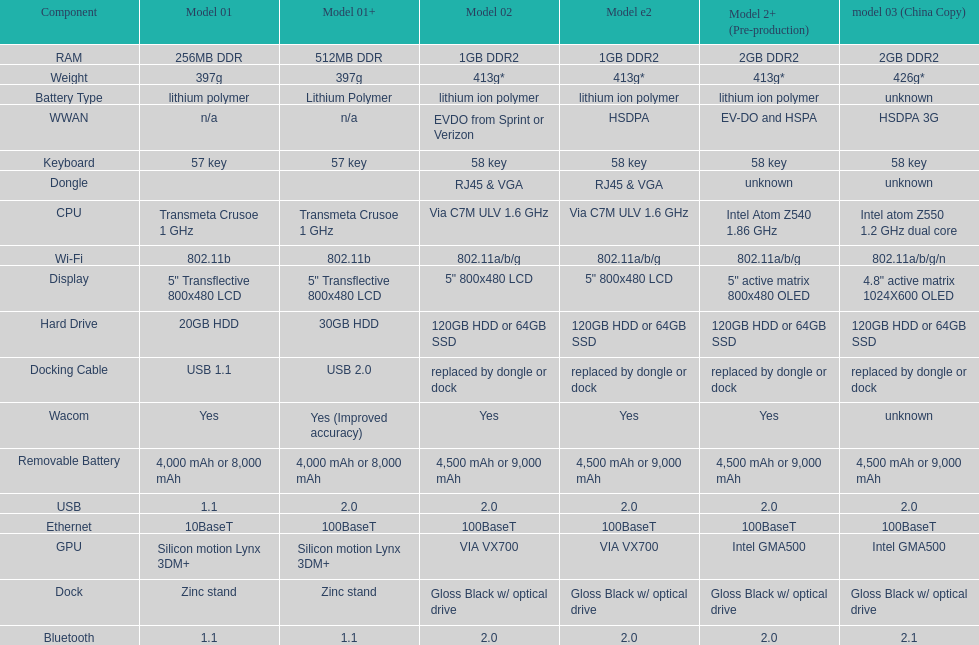How many models have 1.6ghz? 2. 